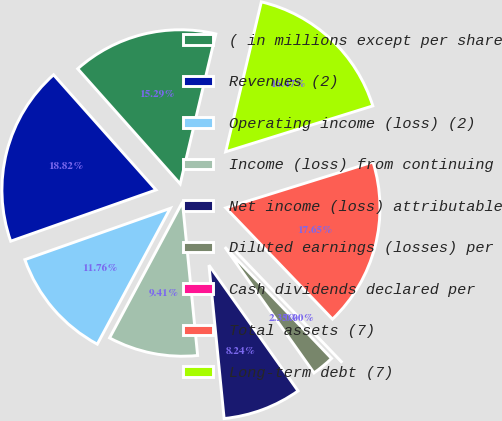Convert chart to OTSL. <chart><loc_0><loc_0><loc_500><loc_500><pie_chart><fcel>( in millions except per share<fcel>Revenues (2)<fcel>Operating income (loss) (2)<fcel>Income (loss) from continuing<fcel>Net income (loss) attributable<fcel>Diluted earnings (losses) per<fcel>Cash dividends declared per<fcel>Total assets (7)<fcel>Long-term debt (7)<nl><fcel>15.29%<fcel>18.82%<fcel>11.76%<fcel>9.41%<fcel>8.24%<fcel>2.35%<fcel>0.0%<fcel>17.65%<fcel>16.47%<nl></chart> 